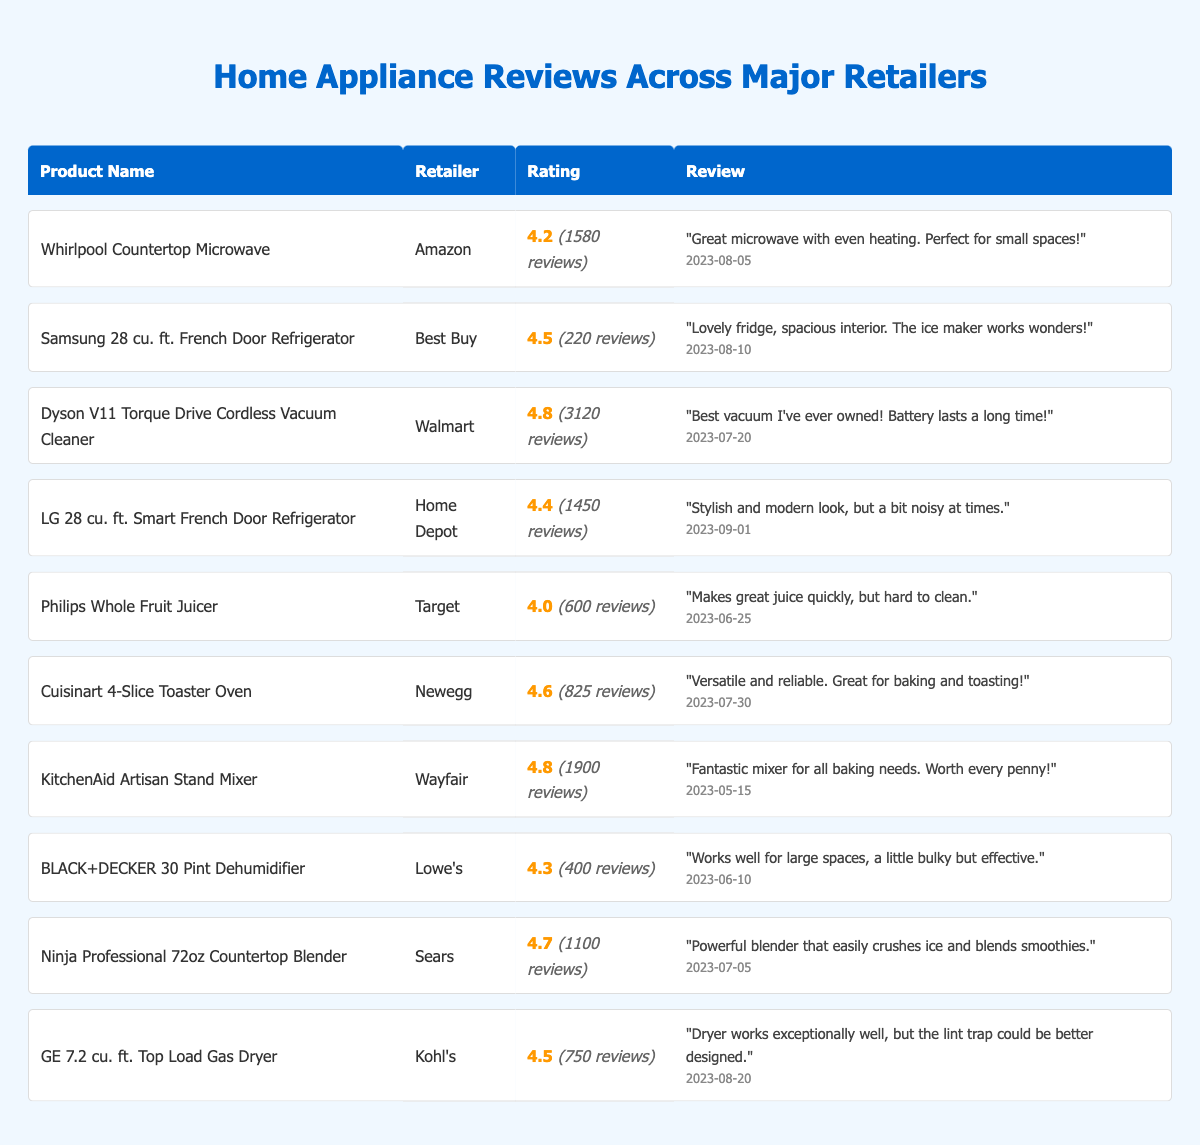What is the highest user rating among the listed appliances? Scanning the table, the highest user rating is 4.8 for both the Dyson V11 Torque Drive Cordless Vacuum Cleaner and the KitchenAid Artisan Stand Mixer.
Answer: 4.8 Which retailer has the Samsung 28 cu. ft. French Door Refrigerator? Referring to the table, the Samsung 28 cu. ft. French Door Refrigerator is listed under Best Buy.
Answer: Best Buy What is the total number of reviews for all listed appliances? Adding up the review counts from the table: 1580 + 220 + 3120 + 1450 + 600 + 825 + 1900 + 400 + 1100 + 750 = 10145.
Answer: 10145 Is the review for the BLACK+DECKER 30 Pint Dehumidifier positive? The review states that it "works well for large spaces" despite being "a little bulky." This indicates a positive sentiment overall.
Answer: Yes Which appliance has the most reviews, and how many does it have? The Dyson V11 Torque Drive Cordless Vacuum Cleaner has the highest number of reviews at 3120.
Answer: Dyson V11 Torque Drive Cordless Vacuum Cleaner, 3120 reviews What is the average user rating of the appliances listed? To find the average rating, sum up the ratings (4.2 + 4.5 + 4.8 + 4.4 + 4.0 + 4.6 + 4.8 + 4.3 + 4.7 + 4.5 = 46.8) and divide by 10, resulting in 46.8 / 10 = 4.68.
Answer: 4.68 Which product has the lowest rating, and what is that rating? The Philips Whole Fruit Juicer has the lowest rating at 4.0, as seen in the table.
Answer: Philips Whole Fruit Juicer, 4.0 How many appliances have a user rating of 4.5 or above? Counting from the table, there are 6 appliances (Samsung, Dyson, LG, Cuisinart, KitchenAid, Ninja, GE).
Answer: 6 What retailer features the most appliances in the list? Analyzing the retailers, the table shows varied entries, but no retailer has multiple appliances; each is listed only once.
Answer: None What is the review date for the LG 28 cu. ft. Smart French Door Refrigerator? The review date for the LG 28 cu. ft. Smart French Door Refrigerator is 2023-09-01, as indicated in the table.
Answer: 2023-09-01 